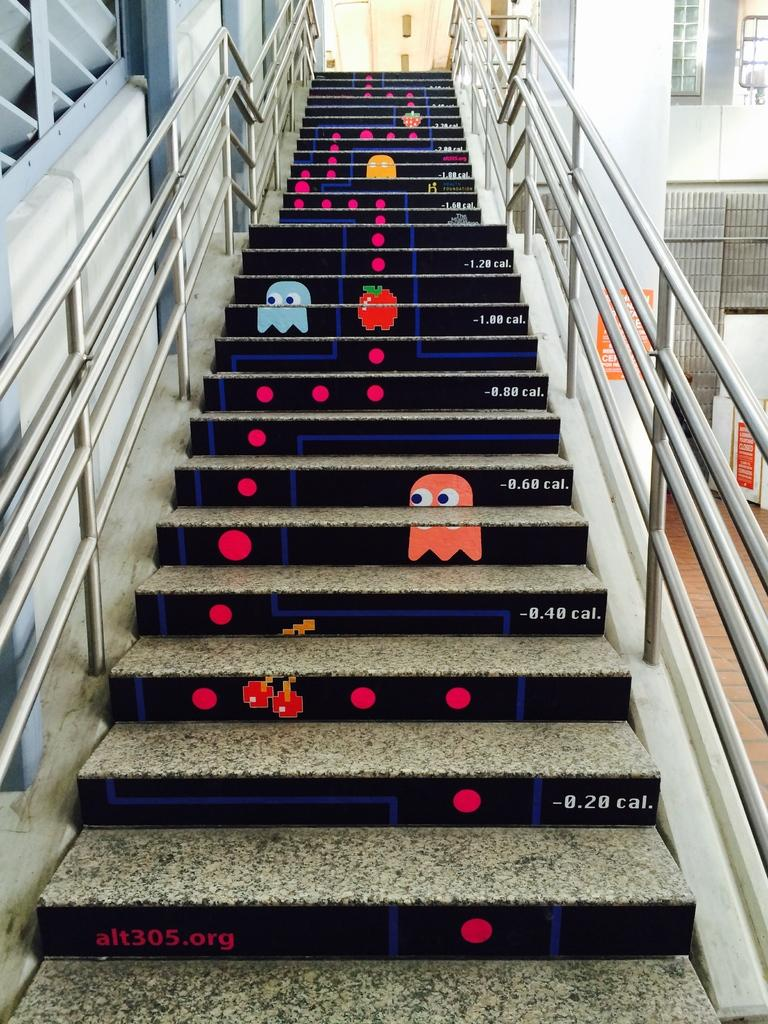What type of architectural feature is present in the image? There are steps with railings in the image. What can be seen on the steps? There are paintings of cartoons and circles on the steps. What is located on the right side of the image? There is a building with windows on the right side of the image. What type of cake is being served for lunch in the image? There is no cake or lunch depicted in the image; it features steps with railings, paintings on the steps, and a building with windows. 